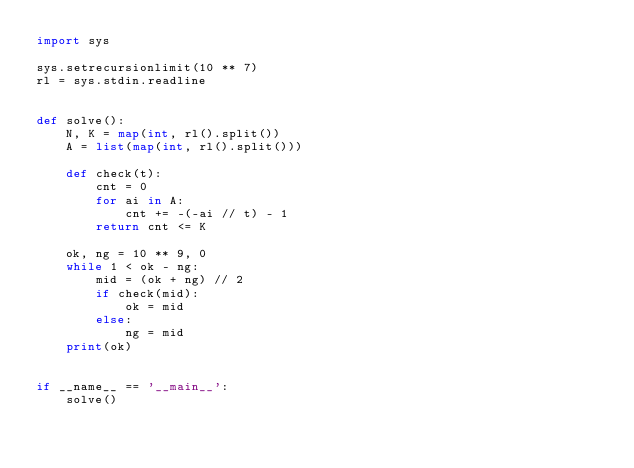Convert code to text. <code><loc_0><loc_0><loc_500><loc_500><_Python_>import sys

sys.setrecursionlimit(10 ** 7)
rl = sys.stdin.readline


def solve():
    N, K = map(int, rl().split())
    A = list(map(int, rl().split()))
    
    def check(t):
        cnt = 0
        for ai in A:
            cnt += -(-ai // t) - 1
        return cnt <= K
    
    ok, ng = 10 ** 9, 0
    while 1 < ok - ng:
        mid = (ok + ng) // 2
        if check(mid):
            ok = mid
        else:
            ng = mid
    print(ok)


if __name__ == '__main__':
    solve()
</code> 